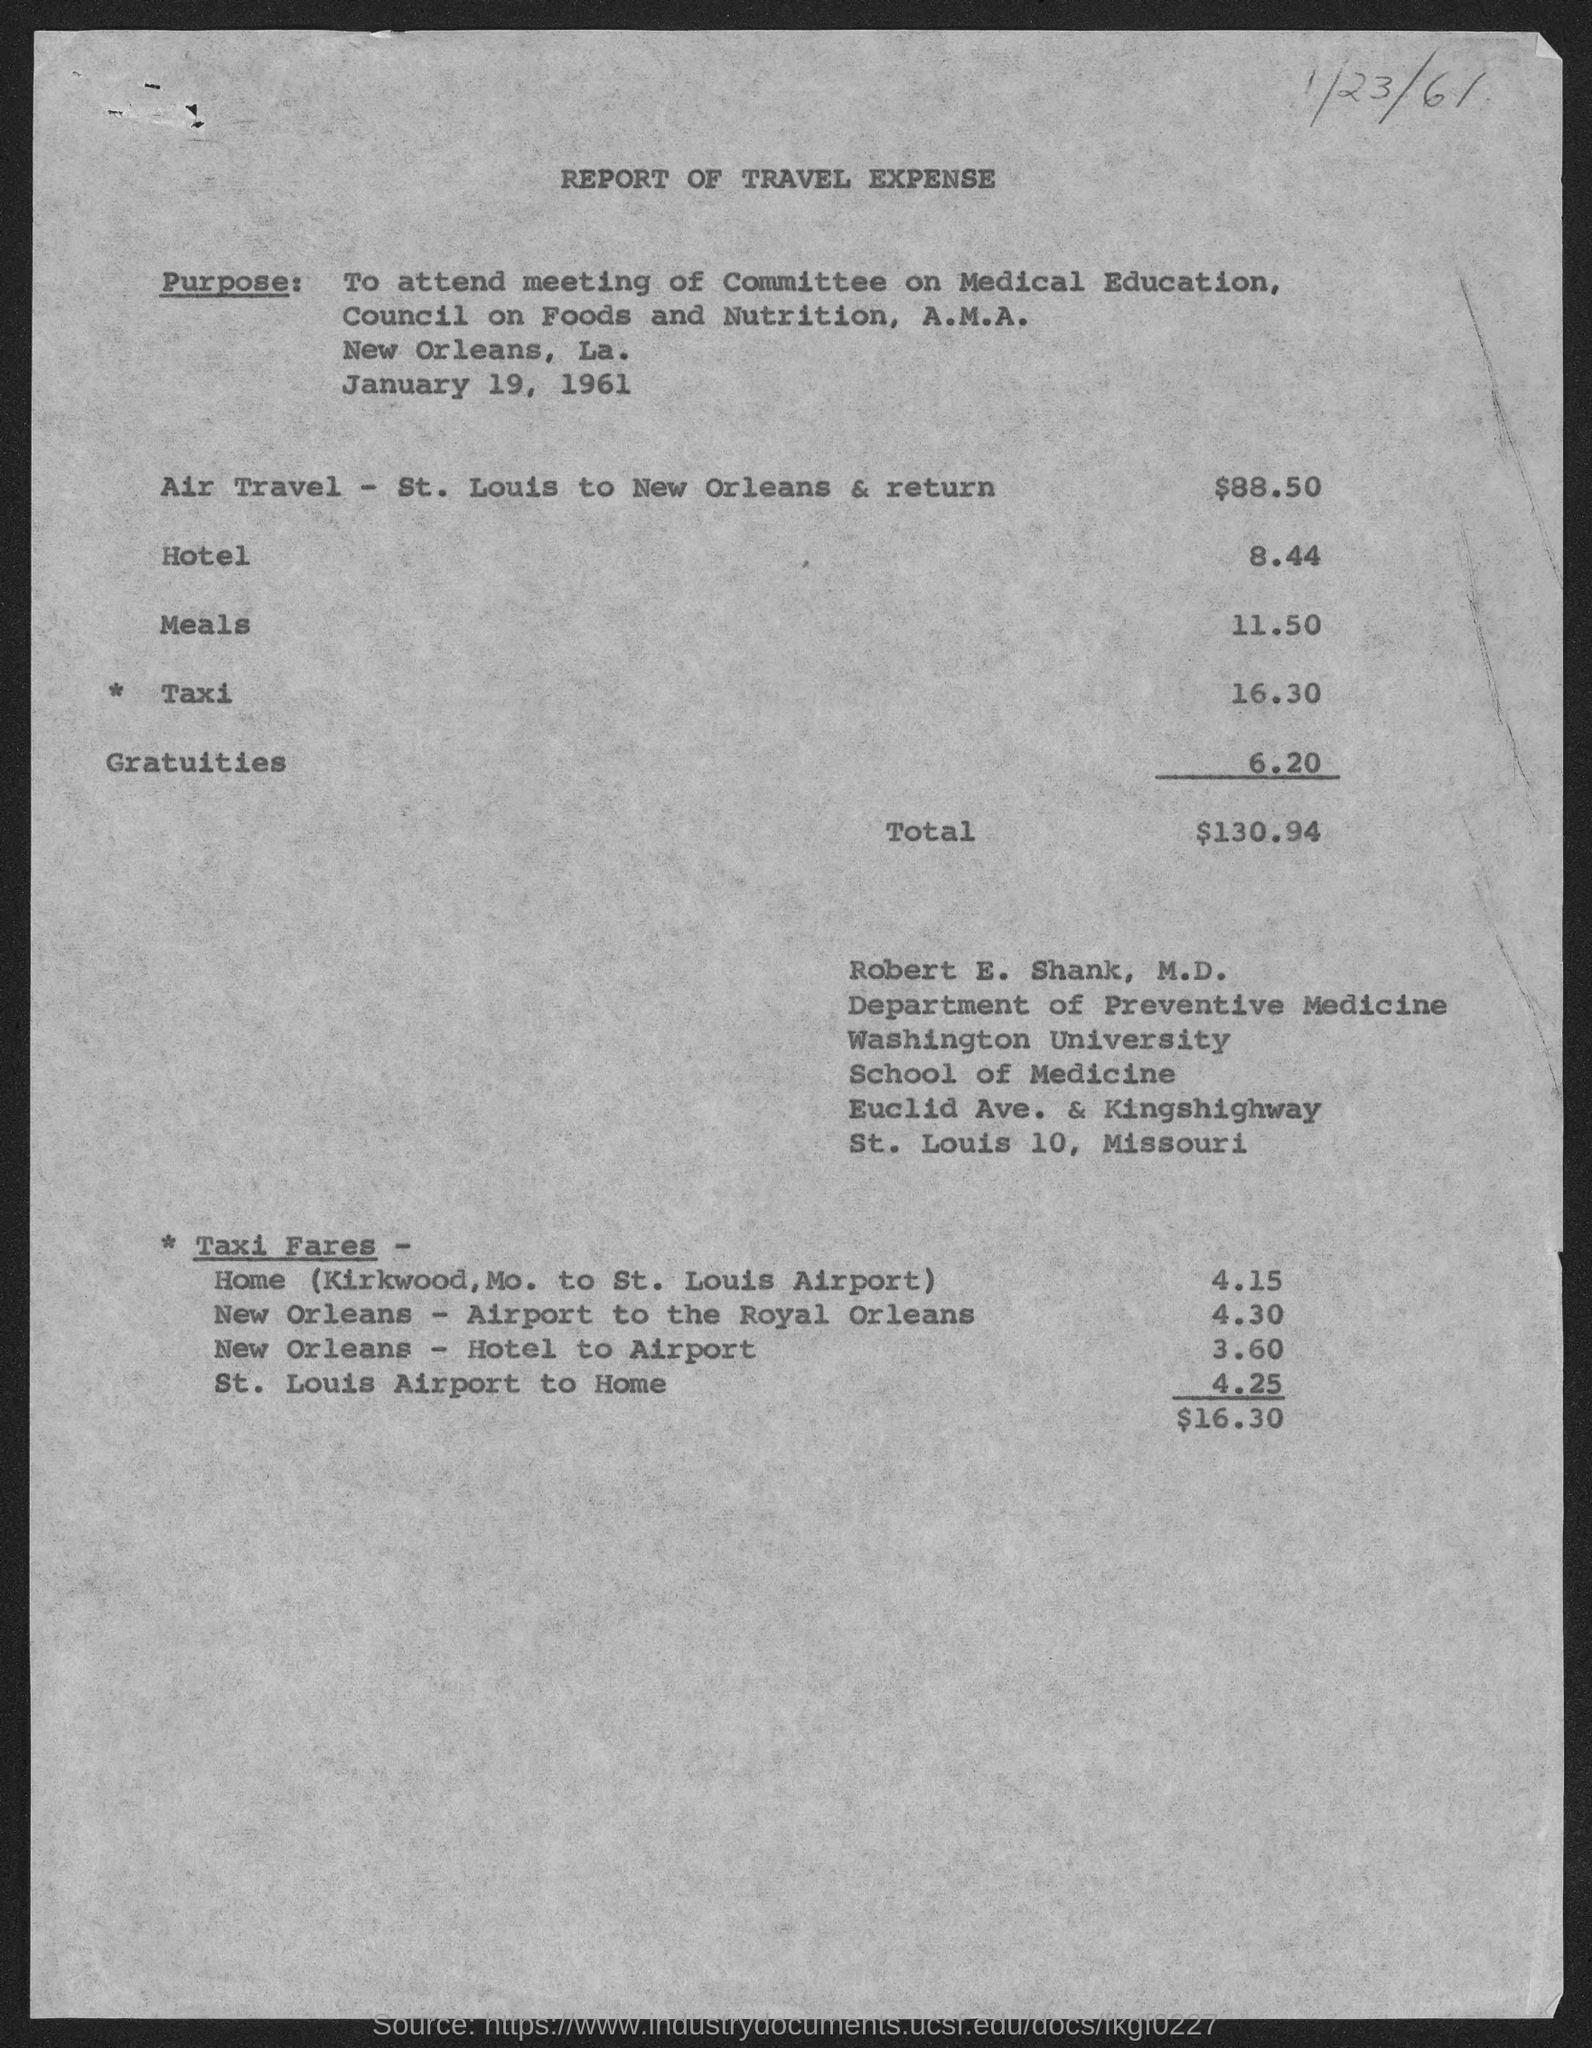Identify some key points in this picture. The air travel expense, as stated in the document, is $88.50. The travel expenses listed in this document are for Robert E. Shank, M.D. The total travel expense mentioned in the document is $130.94. 